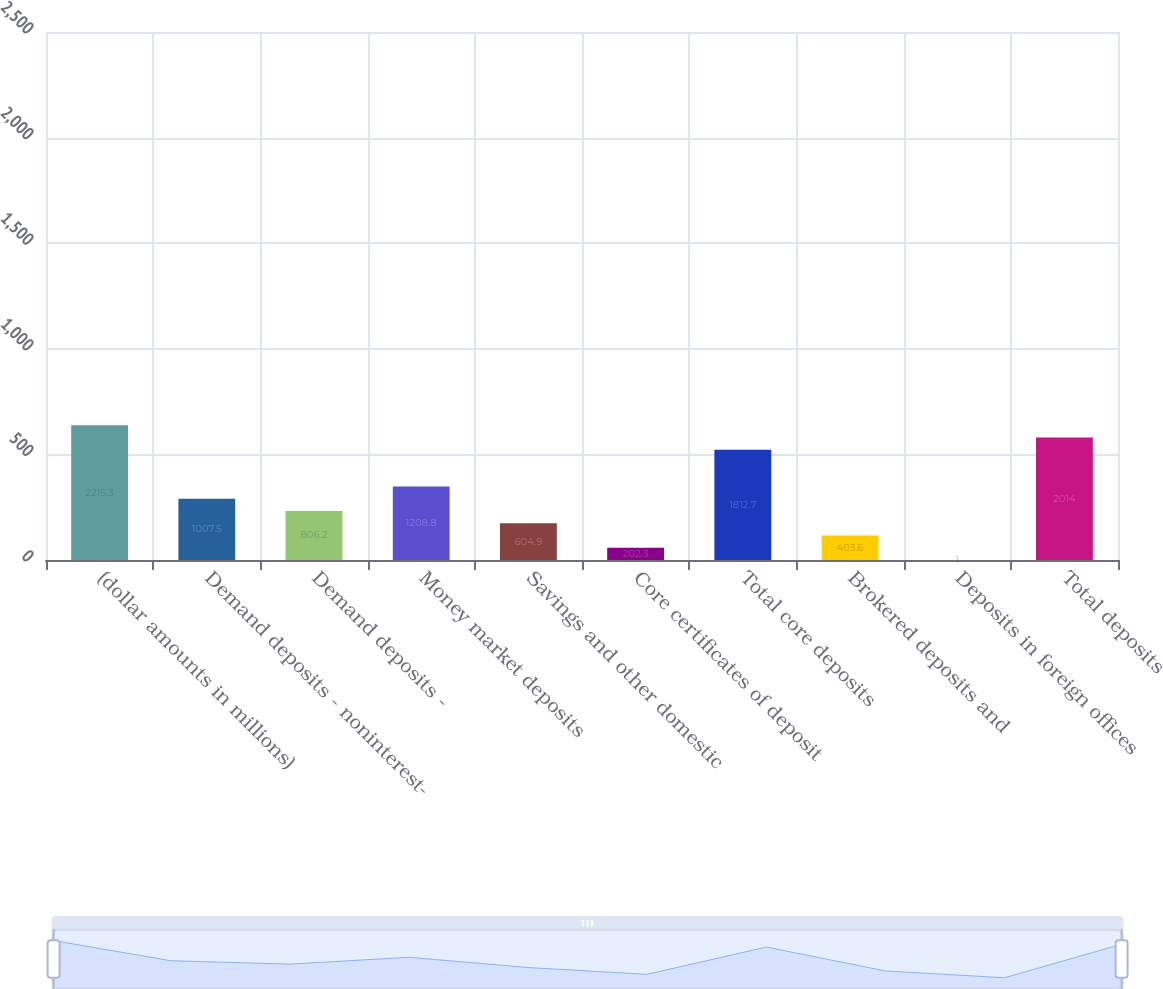Convert chart. <chart><loc_0><loc_0><loc_500><loc_500><bar_chart><fcel>(dollar amounts in millions)<fcel>Demand deposits - noninterest-<fcel>Demand deposits -<fcel>Money market deposits<fcel>Savings and other domestic<fcel>Core certificates of deposit<fcel>Total core deposits<fcel>Brokered deposits and<fcel>Deposits in foreign offices<fcel>Total deposits<nl><fcel>2215.3<fcel>1007.5<fcel>806.2<fcel>1208.8<fcel>604.9<fcel>202.3<fcel>1812.7<fcel>403.6<fcel>1<fcel>2014<nl></chart> 